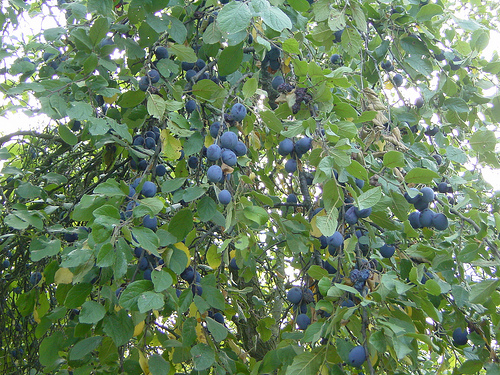<image>
Is the berry behind the leaf? No. The berry is not behind the leaf. From this viewpoint, the berry appears to be positioned elsewhere in the scene. 